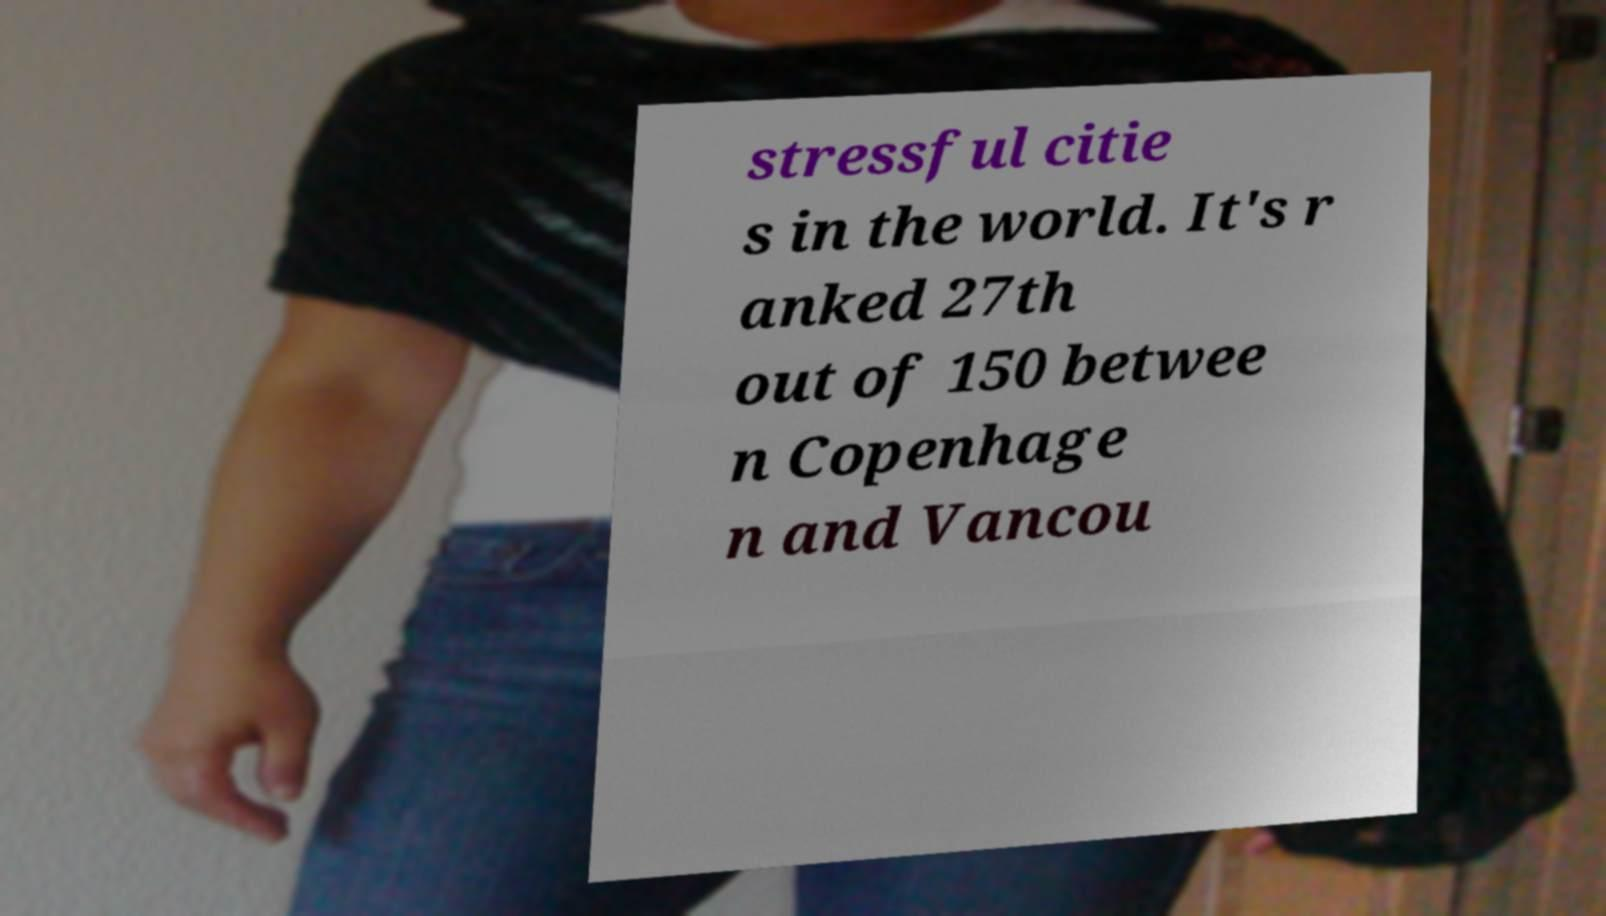There's text embedded in this image that I need extracted. Can you transcribe it verbatim? stressful citie s in the world. It's r anked 27th out of 150 betwee n Copenhage n and Vancou 